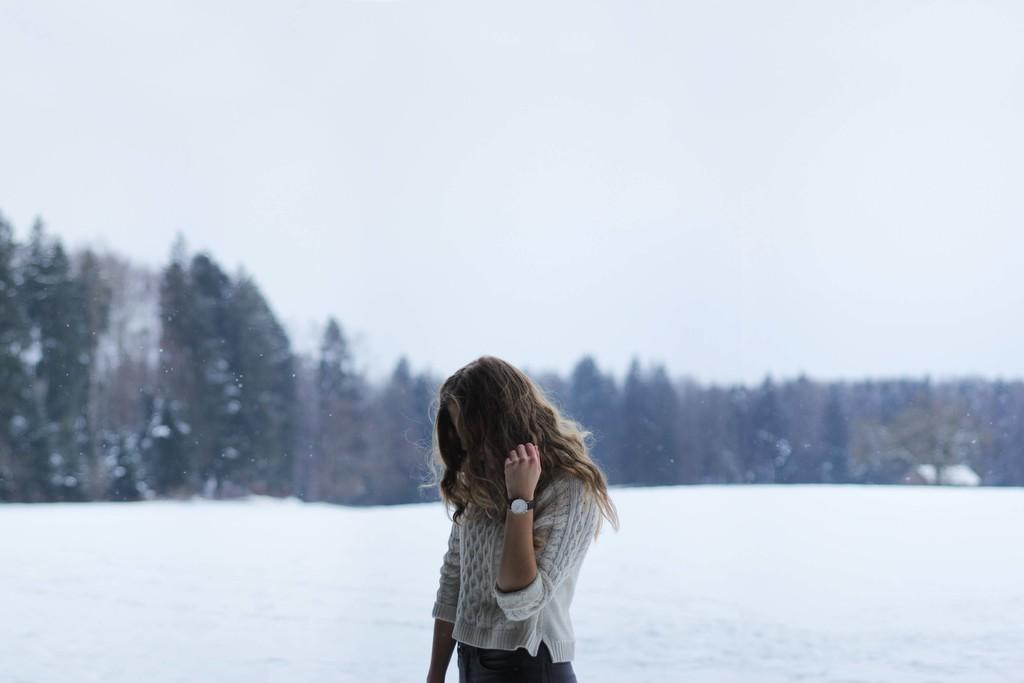What is the main subject of the image? There is a woman standing in the image. What is the woman wearing? The woman is wearing a white dress. What can be seen in the background of the image? There are trees and a snow land in the background of the image. What is visible at the top of the image? The sky is visible at the top of the image. What is the title of the book the woman is holding in the image? There is no book visible in the image, so it is not possible to determine the title. Can you describe the behavior of the twig in the image? There is no twig present in the image, so it is not possible to describe its behavior. 